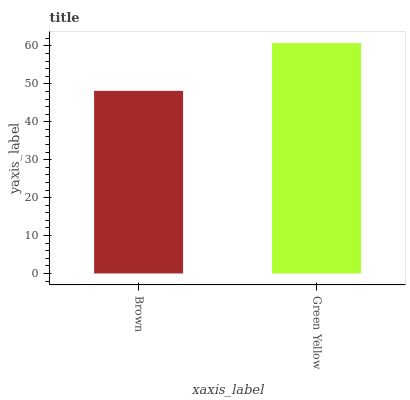Is Brown the minimum?
Answer yes or no. Yes. Is Green Yellow the maximum?
Answer yes or no. Yes. Is Green Yellow the minimum?
Answer yes or no. No. Is Green Yellow greater than Brown?
Answer yes or no. Yes. Is Brown less than Green Yellow?
Answer yes or no. Yes. Is Brown greater than Green Yellow?
Answer yes or no. No. Is Green Yellow less than Brown?
Answer yes or no. No. Is Green Yellow the high median?
Answer yes or no. Yes. Is Brown the low median?
Answer yes or no. Yes. Is Brown the high median?
Answer yes or no. No. Is Green Yellow the low median?
Answer yes or no. No. 